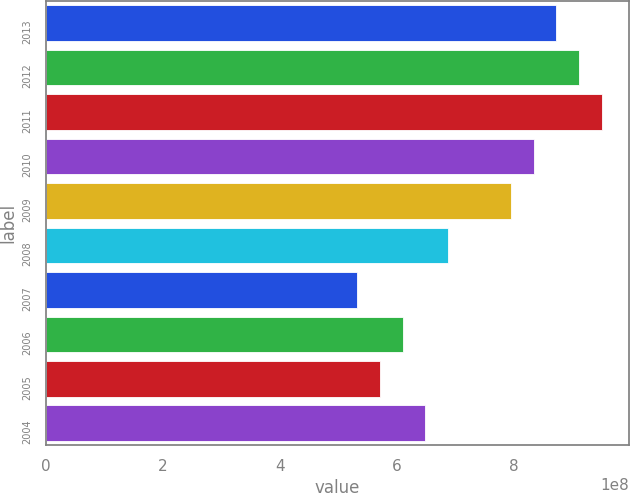Convert chart to OTSL. <chart><loc_0><loc_0><loc_500><loc_500><bar_chart><fcel>2013<fcel>2012<fcel>2011<fcel>2010<fcel>2009<fcel>2008<fcel>2007<fcel>2006<fcel>2005<fcel>2004<nl><fcel>8.72495e+08<fcel>9.11208e+08<fcel>9.49921e+08<fcel>8.33781e+08<fcel>7.95068e+08<fcel>6.87525e+08<fcel>5.32672e+08<fcel>6.10098e+08<fcel>5.71385e+08<fcel>6.48812e+08<nl></chart> 